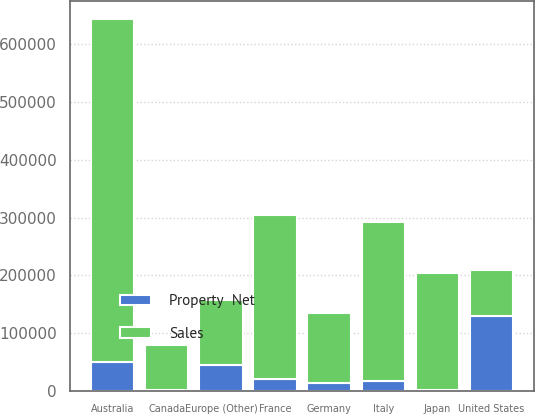<chart> <loc_0><loc_0><loc_500><loc_500><stacked_bar_chart><ecel><fcel>United States<fcel>Australia<fcel>France<fcel>Italy<fcel>Japan<fcel>Germany<fcel>Europe (Other)<fcel>Canada<nl><fcel>Sales<fcel>79420<fcel>592285<fcel>283959<fcel>275047<fcel>203521<fcel>120236<fcel>112408<fcel>79420<nl><fcel>Property  Net<fcel>130029<fcel>50671<fcel>20937<fcel>16941<fcel>1547<fcel>14102<fcel>44608<fcel>1289<nl></chart> 